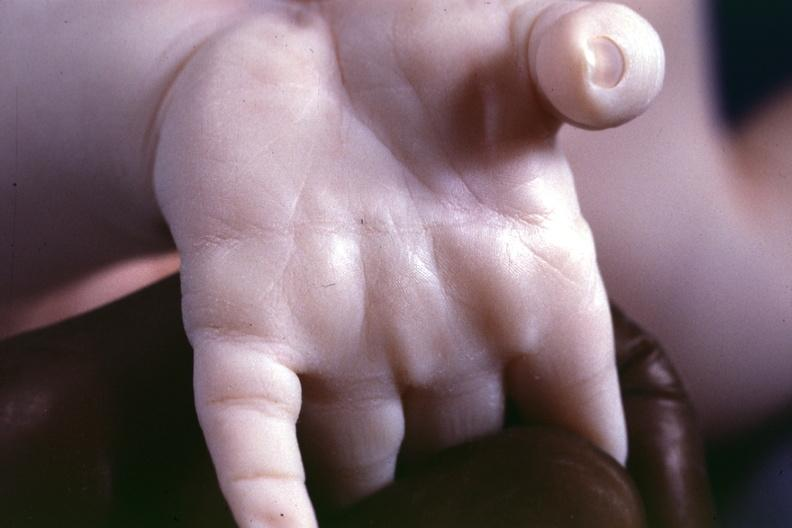s hand present?
Answer the question using a single word or phrase. Yes 